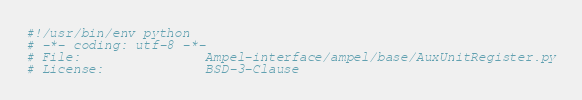<code> <loc_0><loc_0><loc_500><loc_500><_Python_>#!/usr/bin/env python
# -*- coding: utf-8 -*-
# File:                Ampel-interface/ampel/base/AuxUnitRegister.py
# License:             BSD-3-Clause</code> 